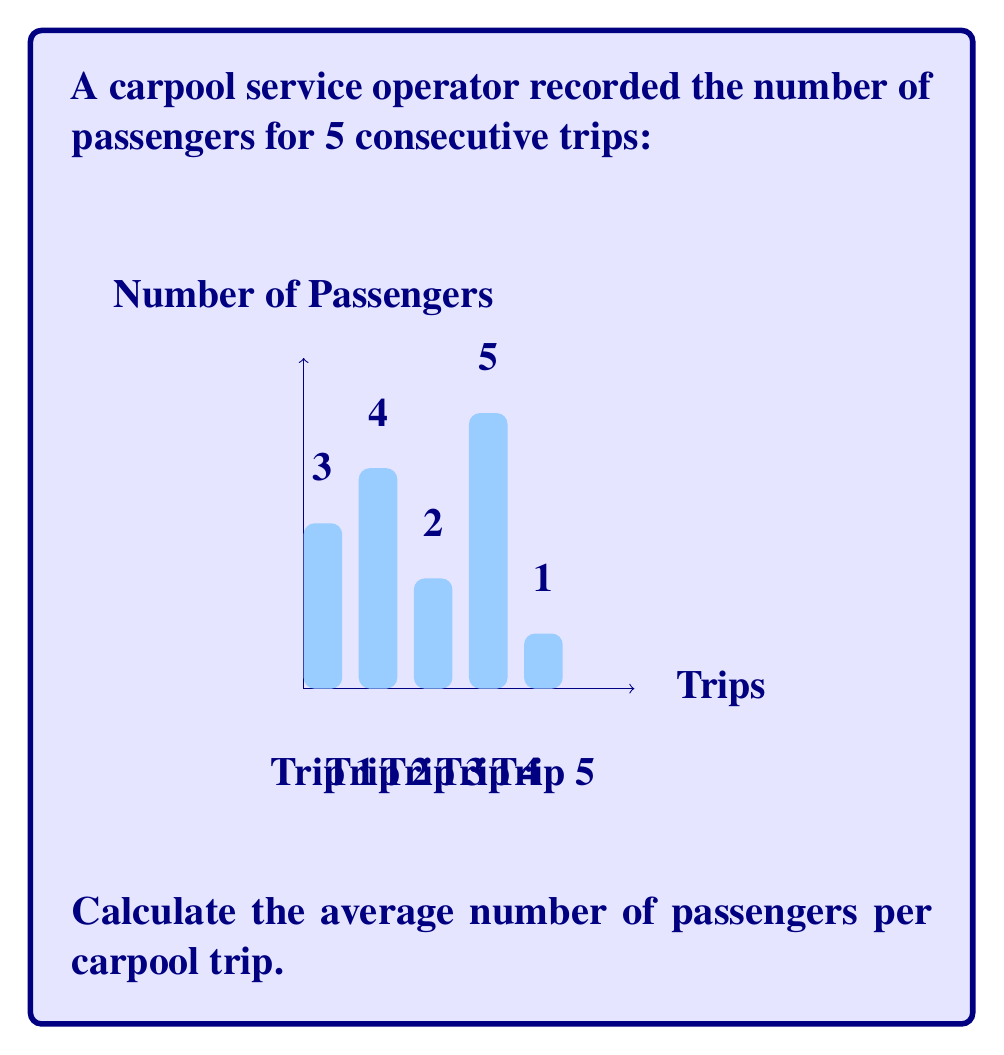Show me your answer to this math problem. To calculate the average number of passengers per carpool trip, we need to:

1. Sum up the total number of passengers across all trips
2. Divide the sum by the total number of trips

Let's follow these steps:

1. Sum of passengers:
   $3 + 4 + 2 + 5 + 1 = 15$

2. Number of trips: 5

3. Calculate the average:
   $$\text{Average} = \frac{\text{Sum of passengers}}{\text{Number of trips}} = \frac{15}{5} = 3$$

Therefore, the average number of passengers per carpool trip is 3.
Answer: $3$ passengers 